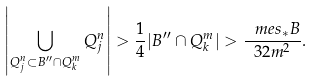<formula> <loc_0><loc_0><loc_500><loc_500>\left | \bigcup _ { Q _ { j } ^ { n } \subset B ^ { \prime \prime } \cap Q _ { k } ^ { m } } Q _ { j } ^ { n } \right | > \frac { 1 } { 4 } | B ^ { \prime \prime } \cap Q _ { k } ^ { m } | > \frac { \ m e s _ { * } B } { 3 2 m ^ { 2 } } .</formula> 